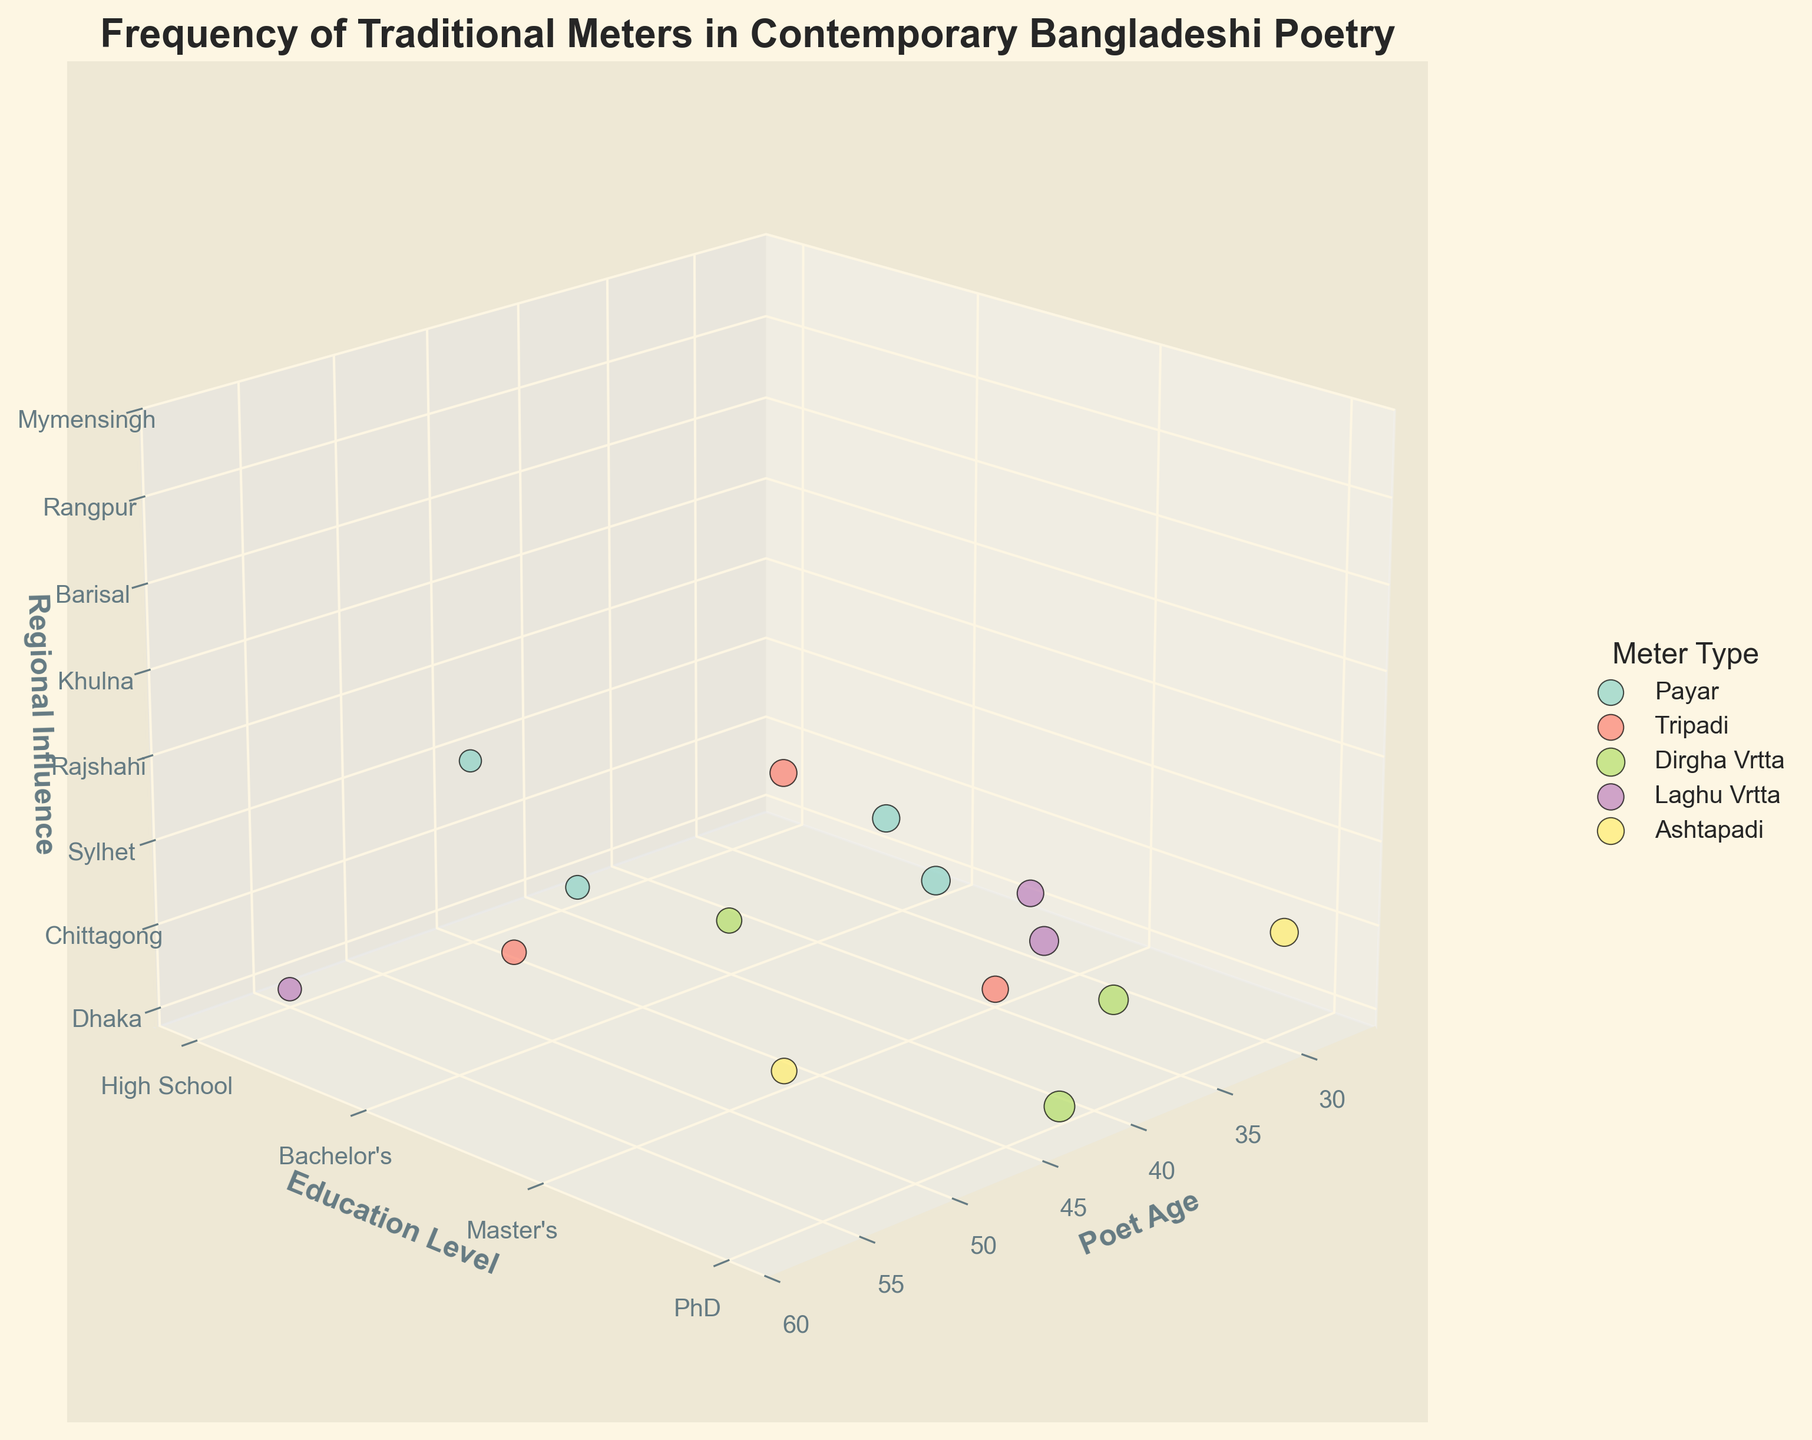What is the title of the figure? The title of the figure is displayed at the top of the chart, indicating the focus of the visualization.
Answer: Frequency of Traditional Meters in Contemporary Bangladeshi Poetry Which meter type has the largest bubble size? The bubble size represents the frequency, so the largest bubble size will correspond to the highest frequency value. The largest bubble can be confirmed visually.
Answer: Dirgha Vrtta Which education level has the most diverse representation of meter types? To find this, we look at the y-axis labels, which represent education levels, and see which level has the most different colored bubbles. Each color represents a different meter type.
Answer: PhD How many poets from Dhaka are represented in the chart? Locate the 'Dhaka' label on the z-axis (Regional Influence) and count the number of bubbles aligned with this label.
Answer: 2 What is the highest frequency of Payar meter type and who does it belong to in terms of age and region? Identify the bubbles corresponding to the 'Payar' meter type, then check which bubble is the largest. Cross-reference with the x-axis (Poet Age) and z-axis (Regional Influence).
Answer: 45, Age 28, Dhaka Between Master's and PhD, which education level shows a higher average frequency for the Tripadi meter type? Average the frequency of Tripadi bubbles for Master's and PhD. Use the y-axis to identify the education levels and compare the averages.
Answer: Master's: (38+0)/1=38, PhD: 37/1=37, therefore Master's Which regional influence is least represented in the chart, and by how many bubbles? Examine the z-axis (Regional Influence) and count the number of bubbles per region. The least represented region has the fewest bubbles.
Answer: Barisal, 1 Identify the age group with significant representation (three or more poets) and which meter types they focus on. Look at the x-axis (Poet Age) and find an age group with at least three bubbles. Check the colors of those bubbles to determine meter types.
Answer: Age 42 (Dirgha Vrtta), Age 47 (Ashtapadi), Age 39 (Dirgha Vrtta) What is the trend of Ashtapadi meter usage across different education levels? Analyze the y-axis positions of the bubbles of Ashtapadi meter type. Check if there is a noticeable increase or decrease from High School to PhD.
Answer: PhD (43), Master's (36) Which age group shows the highest average frequency of traditional meters across all regions? Calculate the average frequency for each age group by summing the frequencies of all bubbles within that age group and dividing by the number of bubbles. Compare these averages.
Answer: 42 (52) 